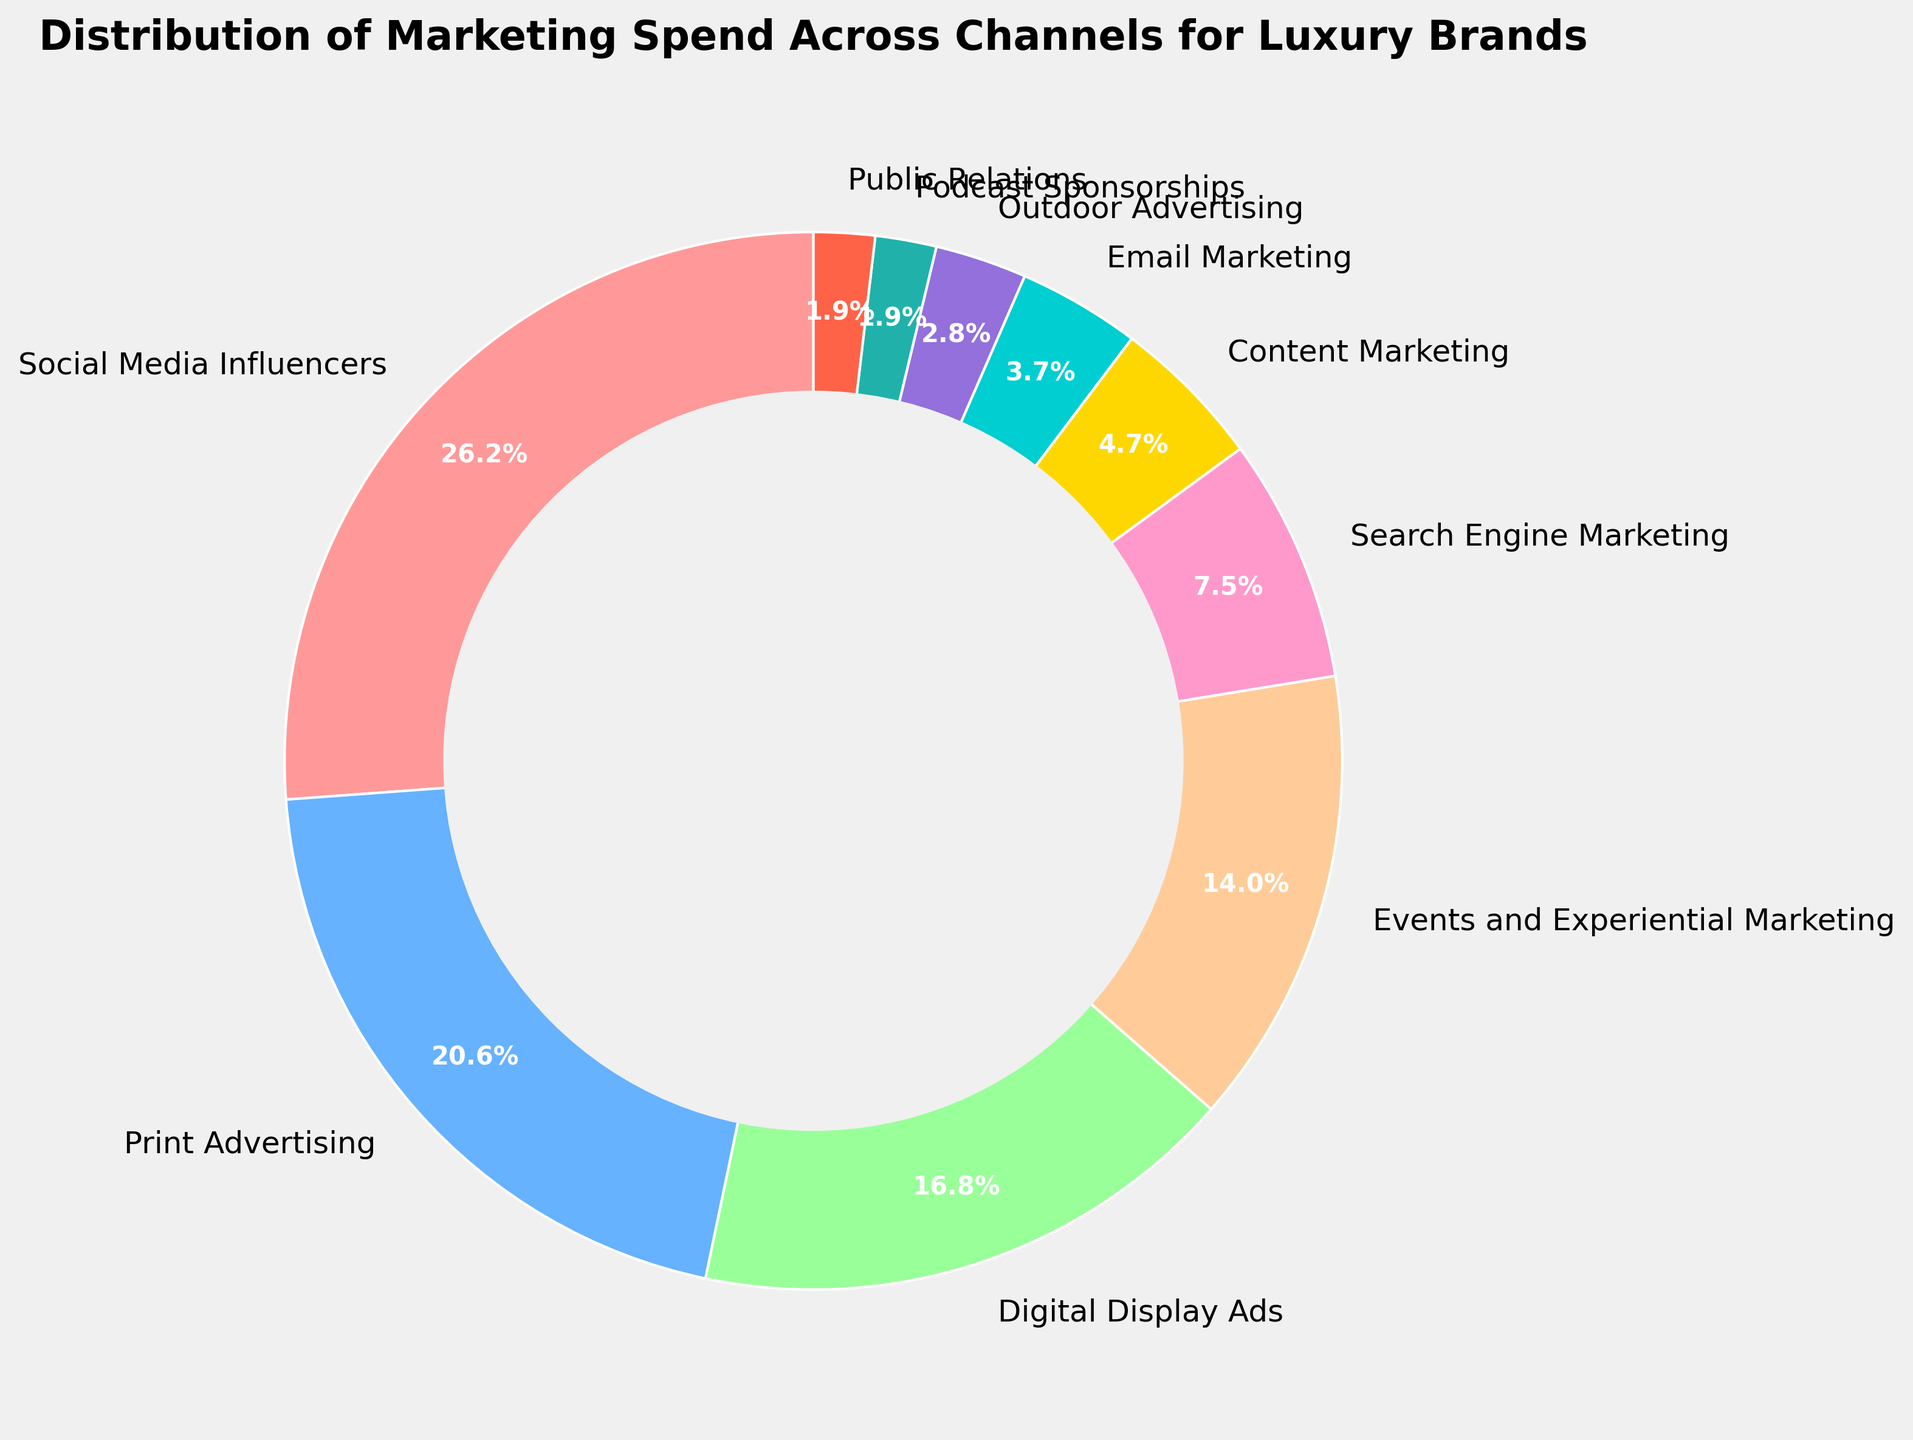What is the largest spending category, and by how much difference compared to the smallest spending category? The largest spending category is "Social Media Influencers" with 28%. The smallest spending categories are "Podcast Sponsorships" and "Public Relations," both with 2%. The difference is 28% - 2% = 26%.
Answer: Social Media Influencers by 26% What is the combined percentage of spending on Print Advertising and Digital Display Ads? Print Advertising has 22%, and Digital Display Ads have 18%. Combined, it is 22% + 18% = 40%.
Answer: 40% Which marketing channel has slightly more investment: Email Marketing or Outdoor Advertising? Email Marketing has 4%, and Outdoor Advertising has 3%. Email Marketing has slightly more investment.
Answer: Email Marketing Is the spending on Content Marketing and Email Marketing more or less than the spending on Search Engine Marketing? By how much more or less? Content Marketing has 5%, and Email Marketing has 4%. Combined, these are 5% + 4% = 9%. Search Engine Marketing has 8%. Therefore, the spending on Content and Email Marketing is 1% more than Search Engine Marketing.
Answer: More by 1% What color represents the Social Media Influencers segment, and why might it have been chosen? The Social Media Influencers segment is represented in red (#FF9999). This choice may have been made because red is a strong, attention-grabbing color, highlighting the significant portion spent on influencers.
Answer: Red Are there more marketing categories under 5% or over 20%? There are three categories under 5% (Email Marketing, Outdoor Advertising, Podcast Sponsorships, and Public Relations), which make seven when combined. There are two categories over 20% (Social Media Influencers and Print Advertising). Hence, there are more marketing categories under 5%.
Answer: Under 5% What is the average percentage spend on Events and Experiential Marketing, Search Engine Marketing, and Content Marketing? Events and Experiential Marketing has 15%, Search Engine Marketing has 8%, and Content Marketing has 5%. The average percentage is (15% + 8% + 5%) / 3 = 28% / 3 ≈ 9.33%.
Answer: 9.33% Which channels combined represent exactly half of the total marketing spend? Print Advertising and Digital Display Ads combined (22% + 18% = 40%) and adding Email Marketing (4%) and Outdoor Advertising (3%), we get 40% + 4% + 3% = 47%. Adding Public Relations (2%), we get 47% + 2% = 49%. Finally, adding Podcast Sponsorships (2%), we get 49% + 2% = 51%. However, these together exceed half, so it doesn’t round up exactly to 50%. But approximately, Print, Digital, Content, Email, Outdoor, Public Relations, and Podcast Sponsorships could be closest to half.
Answer: Approximately, Print, Digital, Email, Outdoor, Public Relations, and Podcast Sponsorships If a new marketing channel is considered and added with a similar percentage as Content Marketing, what will be the new average marketing spend across all channels? Content Marketing has 5%. Currently, there are 10 channels. Adding one new channel makes it 11. Total percentage for 10 channels is 100%. Adding 5% makes it 105%. The new average across 11 channels is 105% / 11 ≈ 9.55%.
Answer: 9.55% 